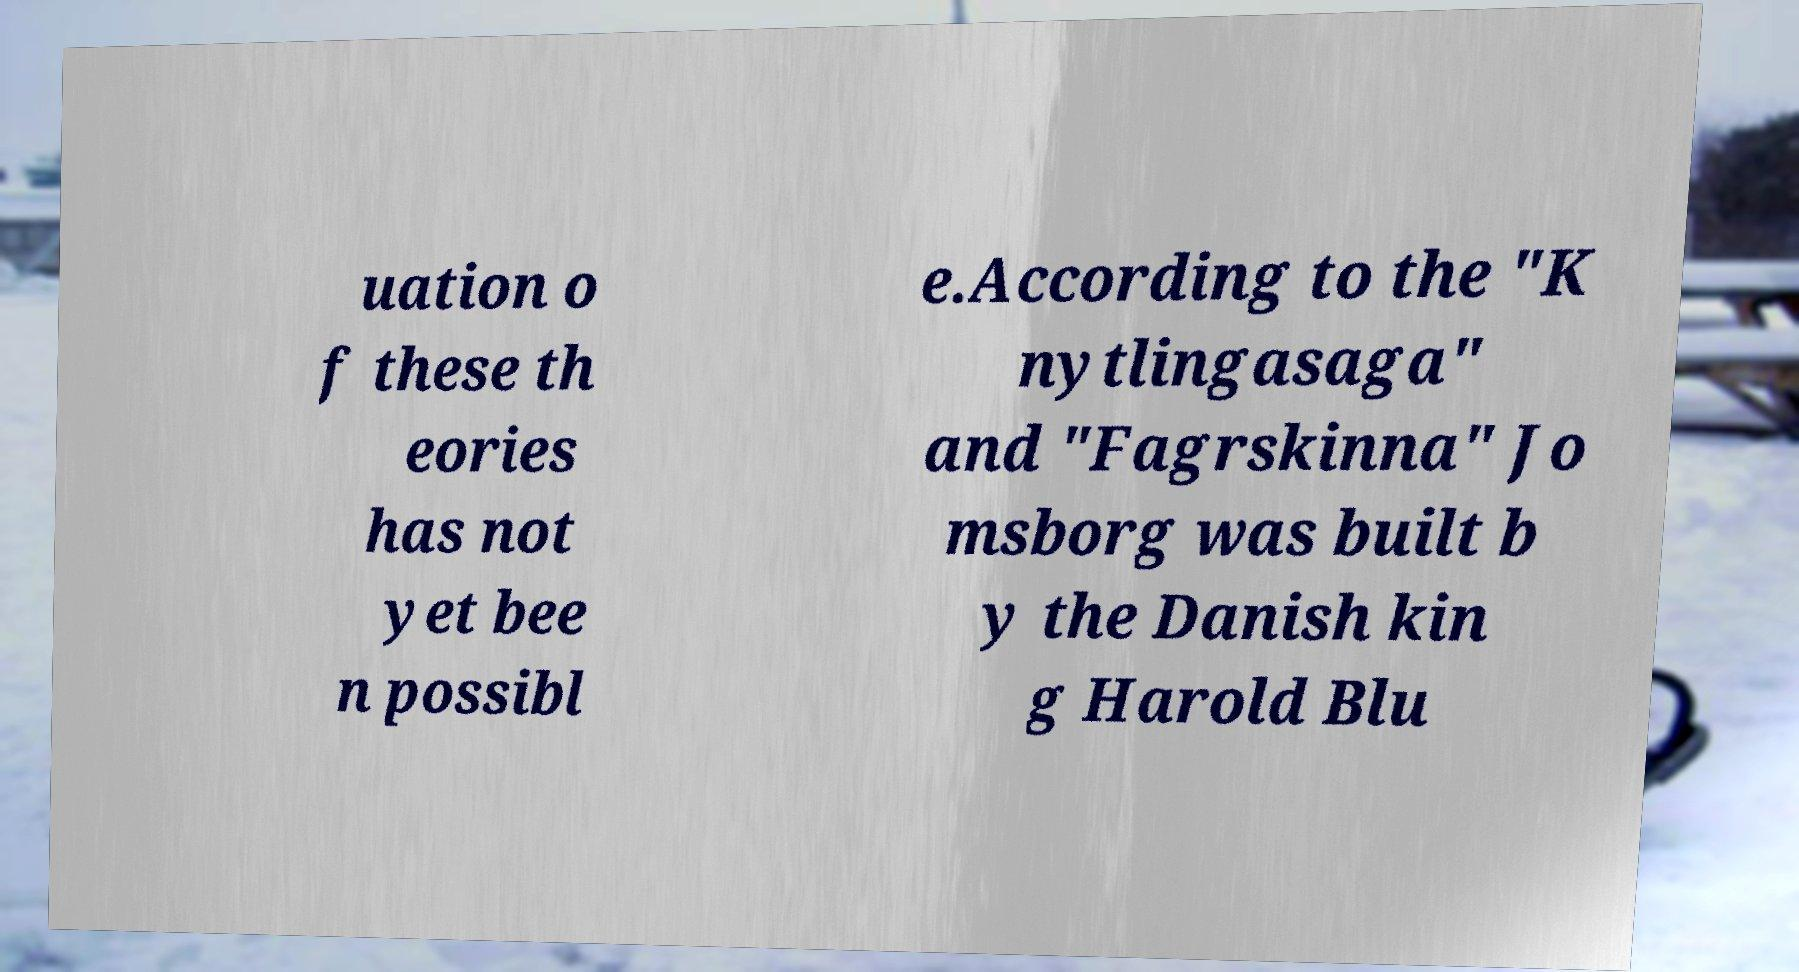There's text embedded in this image that I need extracted. Can you transcribe it verbatim? uation o f these th eories has not yet bee n possibl e.According to the "K nytlingasaga" and "Fagrskinna" Jo msborg was built b y the Danish kin g Harold Blu 